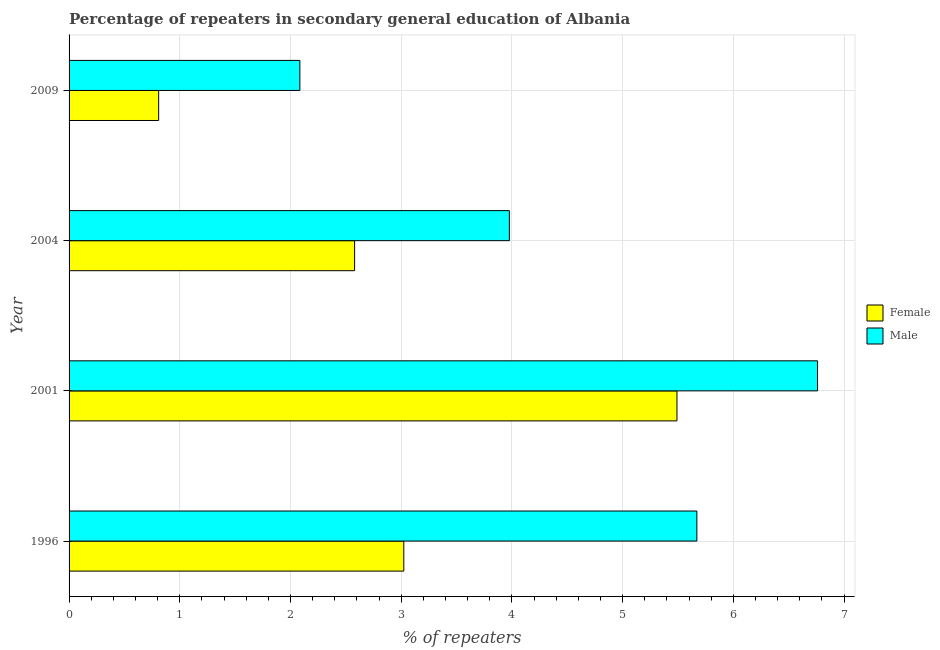How many groups of bars are there?
Give a very brief answer. 4. What is the label of the 3rd group of bars from the top?
Keep it short and to the point. 2001. In how many cases, is the number of bars for a given year not equal to the number of legend labels?
Make the answer very short. 0. What is the percentage of female repeaters in 1996?
Ensure brevity in your answer.  3.02. Across all years, what is the maximum percentage of female repeaters?
Give a very brief answer. 5.49. Across all years, what is the minimum percentage of female repeaters?
Your answer should be compact. 0.81. In which year was the percentage of female repeaters minimum?
Provide a short and direct response. 2009. What is the total percentage of male repeaters in the graph?
Offer a very short reply. 18.49. What is the difference between the percentage of female repeaters in 2001 and that in 2009?
Offer a terse response. 4.68. What is the difference between the percentage of female repeaters in 2004 and the percentage of male repeaters in 2001?
Provide a short and direct response. -4.18. What is the average percentage of female repeaters per year?
Your answer should be very brief. 2.98. In the year 1996, what is the difference between the percentage of male repeaters and percentage of female repeaters?
Give a very brief answer. 2.65. What is the ratio of the percentage of female repeaters in 2001 to that in 2009?
Your answer should be very brief. 6.79. Is the percentage of male repeaters in 1996 less than that in 2009?
Offer a very short reply. No. Is the difference between the percentage of male repeaters in 1996 and 2004 greater than the difference between the percentage of female repeaters in 1996 and 2004?
Give a very brief answer. Yes. What is the difference between the highest and the second highest percentage of male repeaters?
Your answer should be very brief. 1.09. What is the difference between the highest and the lowest percentage of female repeaters?
Ensure brevity in your answer.  4.68. In how many years, is the percentage of female repeaters greater than the average percentage of female repeaters taken over all years?
Your answer should be compact. 2. Are all the bars in the graph horizontal?
Give a very brief answer. Yes. How many years are there in the graph?
Offer a terse response. 4. What is the difference between two consecutive major ticks on the X-axis?
Offer a very short reply. 1. Where does the legend appear in the graph?
Give a very brief answer. Center right. What is the title of the graph?
Your answer should be very brief. Percentage of repeaters in secondary general education of Albania. Does "Formally registered" appear as one of the legend labels in the graph?
Keep it short and to the point. No. What is the label or title of the X-axis?
Provide a short and direct response. % of repeaters. What is the label or title of the Y-axis?
Offer a terse response. Year. What is the % of repeaters in Female in 1996?
Your answer should be compact. 3.02. What is the % of repeaters in Male in 1996?
Offer a terse response. 5.67. What is the % of repeaters of Female in 2001?
Your answer should be very brief. 5.49. What is the % of repeaters of Male in 2001?
Offer a terse response. 6.76. What is the % of repeaters in Female in 2004?
Provide a succinct answer. 2.58. What is the % of repeaters of Male in 2004?
Your answer should be compact. 3.98. What is the % of repeaters in Female in 2009?
Keep it short and to the point. 0.81. What is the % of repeaters in Male in 2009?
Provide a short and direct response. 2.08. Across all years, what is the maximum % of repeaters of Female?
Your response must be concise. 5.49. Across all years, what is the maximum % of repeaters of Male?
Your answer should be compact. 6.76. Across all years, what is the minimum % of repeaters in Female?
Give a very brief answer. 0.81. Across all years, what is the minimum % of repeaters in Male?
Your answer should be compact. 2.08. What is the total % of repeaters in Female in the graph?
Provide a short and direct response. 11.9. What is the total % of repeaters of Male in the graph?
Your answer should be very brief. 18.49. What is the difference between the % of repeaters in Female in 1996 and that in 2001?
Ensure brevity in your answer.  -2.47. What is the difference between the % of repeaters of Male in 1996 and that in 2001?
Make the answer very short. -1.09. What is the difference between the % of repeaters of Female in 1996 and that in 2004?
Provide a short and direct response. 0.44. What is the difference between the % of repeaters of Male in 1996 and that in 2004?
Keep it short and to the point. 1.69. What is the difference between the % of repeaters of Female in 1996 and that in 2009?
Give a very brief answer. 2.21. What is the difference between the % of repeaters of Male in 1996 and that in 2009?
Provide a succinct answer. 3.59. What is the difference between the % of repeaters of Female in 2001 and that in 2004?
Ensure brevity in your answer.  2.91. What is the difference between the % of repeaters of Male in 2001 and that in 2004?
Your response must be concise. 2.78. What is the difference between the % of repeaters in Female in 2001 and that in 2009?
Make the answer very short. 4.68. What is the difference between the % of repeaters of Male in 2001 and that in 2009?
Your response must be concise. 4.68. What is the difference between the % of repeaters of Female in 2004 and that in 2009?
Your answer should be very brief. 1.77. What is the difference between the % of repeaters of Male in 2004 and that in 2009?
Keep it short and to the point. 1.89. What is the difference between the % of repeaters in Female in 1996 and the % of repeaters in Male in 2001?
Offer a very short reply. -3.74. What is the difference between the % of repeaters of Female in 1996 and the % of repeaters of Male in 2004?
Ensure brevity in your answer.  -0.95. What is the difference between the % of repeaters in Female in 1996 and the % of repeaters in Male in 2009?
Offer a terse response. 0.94. What is the difference between the % of repeaters of Female in 2001 and the % of repeaters of Male in 2004?
Offer a terse response. 1.51. What is the difference between the % of repeaters of Female in 2001 and the % of repeaters of Male in 2009?
Your answer should be compact. 3.41. What is the difference between the % of repeaters in Female in 2004 and the % of repeaters in Male in 2009?
Ensure brevity in your answer.  0.49. What is the average % of repeaters of Female per year?
Your answer should be very brief. 2.98. What is the average % of repeaters in Male per year?
Give a very brief answer. 4.62. In the year 1996, what is the difference between the % of repeaters in Female and % of repeaters in Male?
Provide a short and direct response. -2.65. In the year 2001, what is the difference between the % of repeaters of Female and % of repeaters of Male?
Your answer should be compact. -1.27. In the year 2004, what is the difference between the % of repeaters of Female and % of repeaters of Male?
Provide a succinct answer. -1.4. In the year 2009, what is the difference between the % of repeaters in Female and % of repeaters in Male?
Provide a short and direct response. -1.28. What is the ratio of the % of repeaters of Female in 1996 to that in 2001?
Provide a succinct answer. 0.55. What is the ratio of the % of repeaters in Male in 1996 to that in 2001?
Your answer should be compact. 0.84. What is the ratio of the % of repeaters in Female in 1996 to that in 2004?
Your response must be concise. 1.17. What is the ratio of the % of repeaters in Male in 1996 to that in 2004?
Give a very brief answer. 1.43. What is the ratio of the % of repeaters of Female in 1996 to that in 2009?
Offer a terse response. 3.74. What is the ratio of the % of repeaters of Male in 1996 to that in 2009?
Offer a terse response. 2.72. What is the ratio of the % of repeaters of Female in 2001 to that in 2004?
Give a very brief answer. 2.13. What is the ratio of the % of repeaters in Female in 2001 to that in 2009?
Provide a succinct answer. 6.79. What is the ratio of the % of repeaters in Male in 2001 to that in 2009?
Ensure brevity in your answer.  3.24. What is the ratio of the % of repeaters of Female in 2004 to that in 2009?
Ensure brevity in your answer.  3.19. What is the ratio of the % of repeaters in Male in 2004 to that in 2009?
Offer a very short reply. 1.91. What is the difference between the highest and the second highest % of repeaters in Female?
Keep it short and to the point. 2.47. What is the difference between the highest and the second highest % of repeaters in Male?
Offer a terse response. 1.09. What is the difference between the highest and the lowest % of repeaters in Female?
Make the answer very short. 4.68. What is the difference between the highest and the lowest % of repeaters of Male?
Your response must be concise. 4.68. 